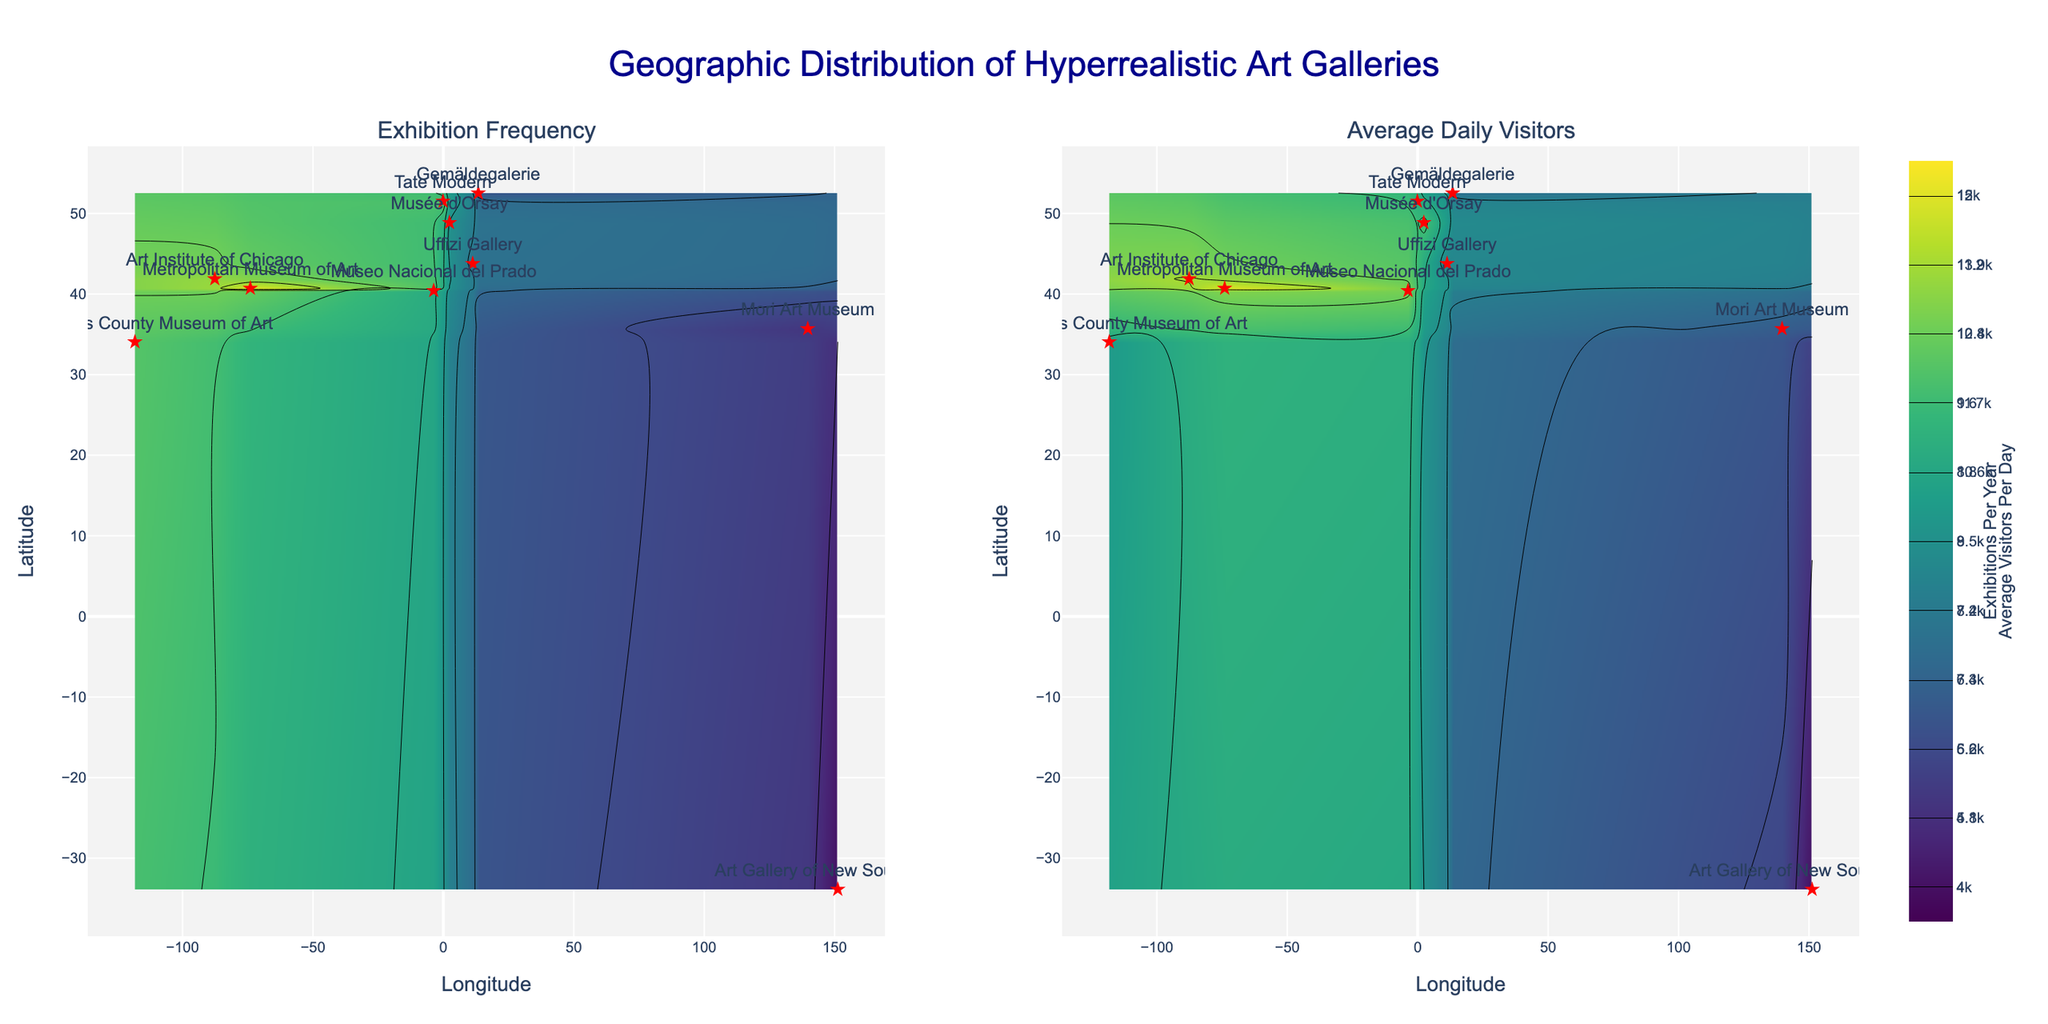What is the title of the figure? The title is displayed at the top center of the figure and is specified as 'Geographic Distribution of Hyperrealistic Art Galleries.'
Answer: Geographic Distribution of Hyperrealistic Art Galleries How many subplots are there in the figure? The figure contains two side-by-side subplots as indicated in the subplot titles and the layout of the figure.
Answer: 2 Which gallery is shown at the rightmost point on the contour plot? Looking at the scatter markers and their positions, the rightmost point in terms of longitude is in Sydney where the 'Art Gallery of New South Wales' is located.
Answer: Art Gallery of New South Wales What is the variable charted on the left subplot? The left subplot is titled "Exhibition Frequency," which indicates that it charts 'exhibitions_per_year.'
Answer: Exhibitions per Year How does the 'Average Daily Visitors' distribution appear in Tokyo? In Tokyo, marked by its longitude (139.6917) and latitude (35.6895), the contour shows color intensity related to 'average_visitors_per_day.' The value can be seen in the hover template or the legend.
Answer: Approximately 7000 Which city has the highest density in terms of average daily visitors? By observing the contour intensities and color gradients on the right subplot, New York has the highest intensity which shows 15000 average visitors per day.
Answer: New York How many major cities from Europe are included in the plot? The figure shows markers for different cities, and visually counting them in Europe, we get Paris, Florence, Madrid, Berlin, and London which sum up to 5 cities.
Answer: 5 Compare the exhibition frequency of New York and Los Angeles. Which has more exhibitions per year? New York has an exhibition frequency of 12 while Los Angeles has 10, which is visible on the left contour plot and hover templates.
Answer: New York What's the average number of visitors per day for the galleries in the United States? Summing up the values for New York (15000), Los Angeles (10000), and Chicago (14000), and then dividing by 3 gives (15000 + 10000 + 14000) / 3 = 13000.
Answer: 13000 What city has the lowest exhibition frequency that's in the plot? By referring to the left subplot's color scale and hover data, Sydney with 'Art Gallery of New South Wales' has the lowest frequency of 4.
Answer: Sydney 